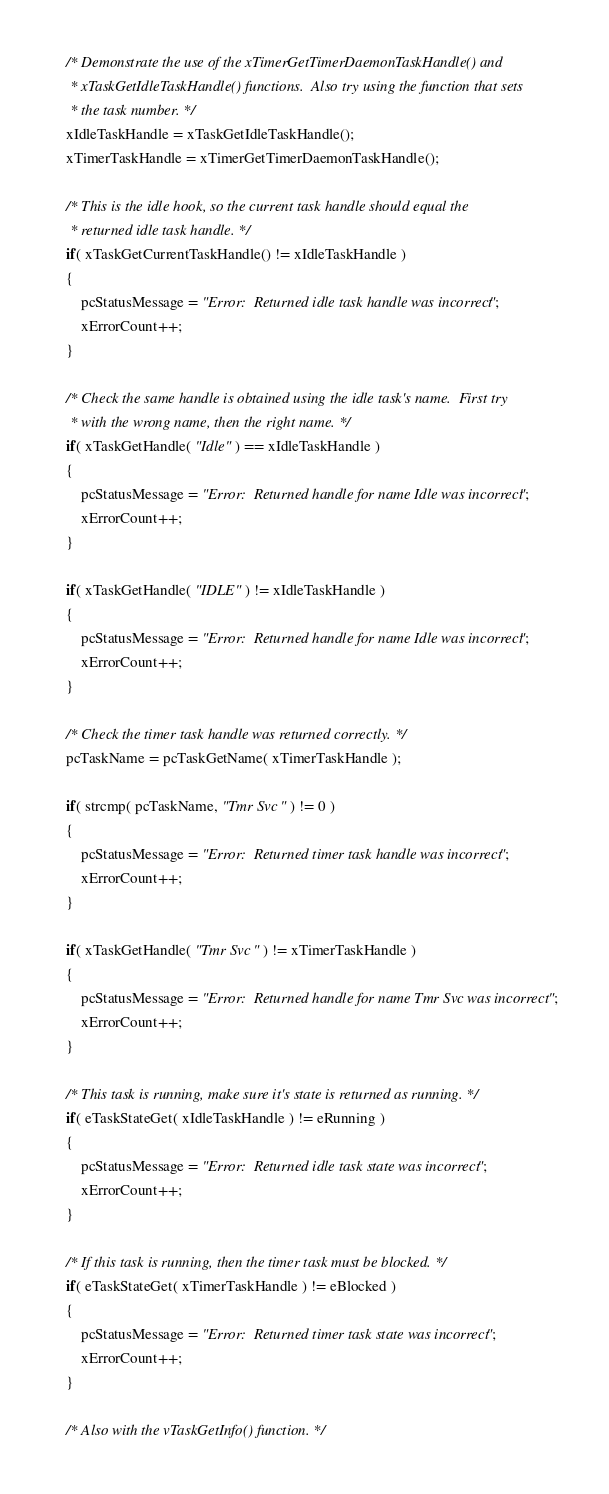<code> <loc_0><loc_0><loc_500><loc_500><_C_>
    /* Demonstrate the use of the xTimerGetTimerDaemonTaskHandle() and
     * xTaskGetIdleTaskHandle() functions.  Also try using the function that sets
     * the task number. */
    xIdleTaskHandle = xTaskGetIdleTaskHandle();
    xTimerTaskHandle = xTimerGetTimerDaemonTaskHandle();

    /* This is the idle hook, so the current task handle should equal the
     * returned idle task handle. */
    if( xTaskGetCurrentTaskHandle() != xIdleTaskHandle )
    {
        pcStatusMessage = "Error:  Returned idle task handle was incorrect";
        xErrorCount++;
    }

    /* Check the same handle is obtained using the idle task's name.  First try
     * with the wrong name, then the right name. */
    if( xTaskGetHandle( "Idle" ) == xIdleTaskHandle )
    {
        pcStatusMessage = "Error:  Returned handle for name Idle was incorrect";
        xErrorCount++;
    }

    if( xTaskGetHandle( "IDLE" ) != xIdleTaskHandle )
    {
        pcStatusMessage = "Error:  Returned handle for name Idle was incorrect";
        xErrorCount++;
    }

    /* Check the timer task handle was returned correctly. */
    pcTaskName = pcTaskGetName( xTimerTaskHandle );

    if( strcmp( pcTaskName, "Tmr Svc" ) != 0 )
    {
        pcStatusMessage = "Error:  Returned timer task handle was incorrect";
        xErrorCount++;
    }

    if( xTaskGetHandle( "Tmr Svc" ) != xTimerTaskHandle )
    {
        pcStatusMessage = "Error:  Returned handle for name Tmr Svc was incorrect";
        xErrorCount++;
    }

    /* This task is running, make sure it's state is returned as running. */
    if( eTaskStateGet( xIdleTaskHandle ) != eRunning )
    {
        pcStatusMessage = "Error:  Returned idle task state was incorrect";
        xErrorCount++;
    }

    /* If this task is running, then the timer task must be blocked. */
    if( eTaskStateGet( xTimerTaskHandle ) != eBlocked )
    {
        pcStatusMessage = "Error:  Returned timer task state was incorrect";
        xErrorCount++;
    }

    /* Also with the vTaskGetInfo() function. */</code> 